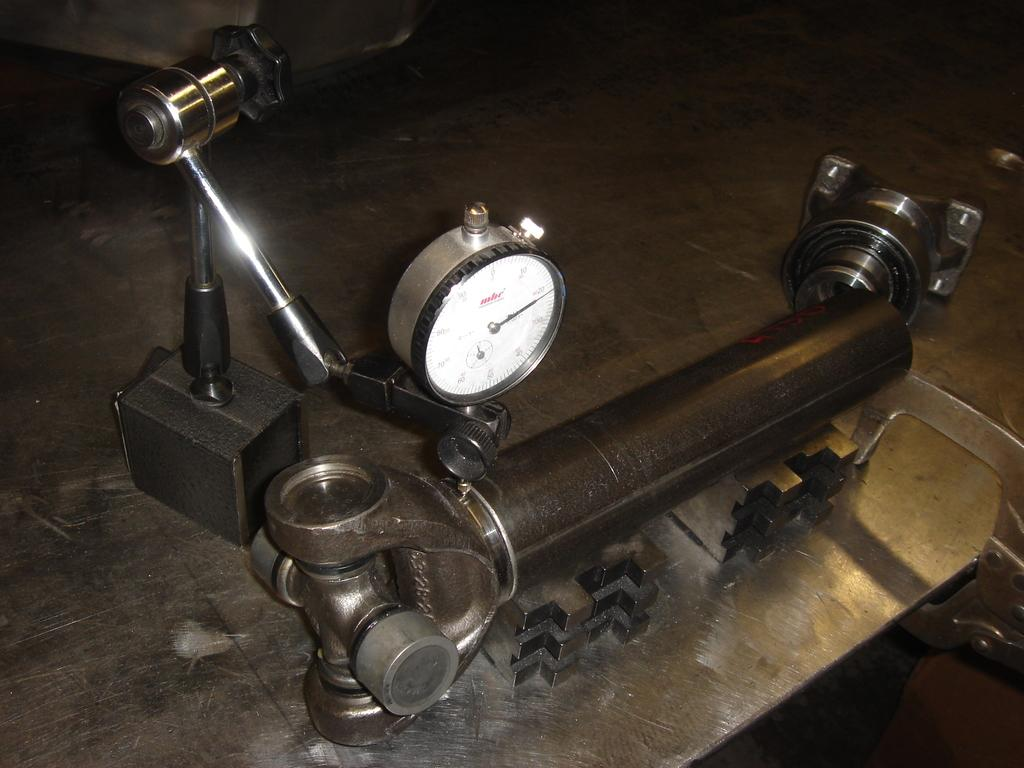What is the main object in the image? There is a machine tool in the image. Where is the machine tool located? The machine tool is placed on a table. What type of drain is visible in the image? There is no drain present in the image; it features a machine tool placed on a table. What kind of lead can be seen being used with the machine tool in the image? There is no lead being used with the machine tool in the image. 